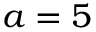Convert formula to latex. <formula><loc_0><loc_0><loc_500><loc_500>a = 5</formula> 